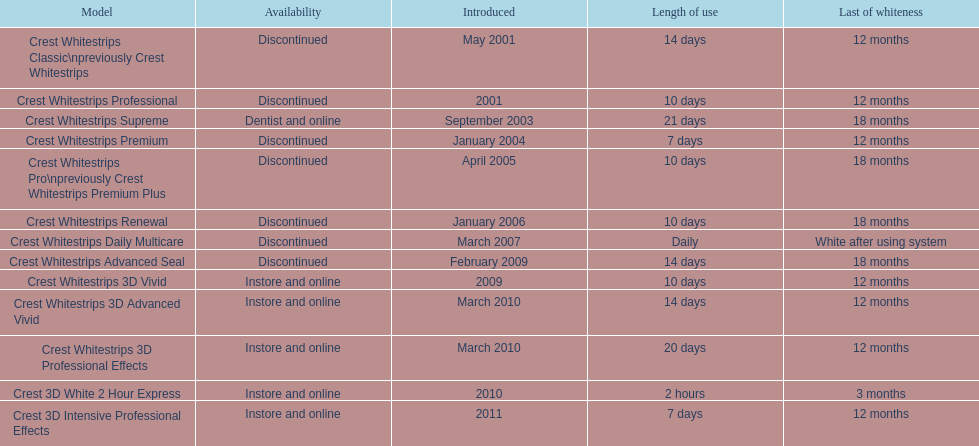Is every white stripe discontinued? No. 